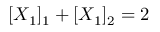<formula> <loc_0><loc_0><loc_500><loc_500>[ X _ { 1 } ] _ { 1 } + [ X _ { 1 } ] _ { 2 } = 2</formula> 